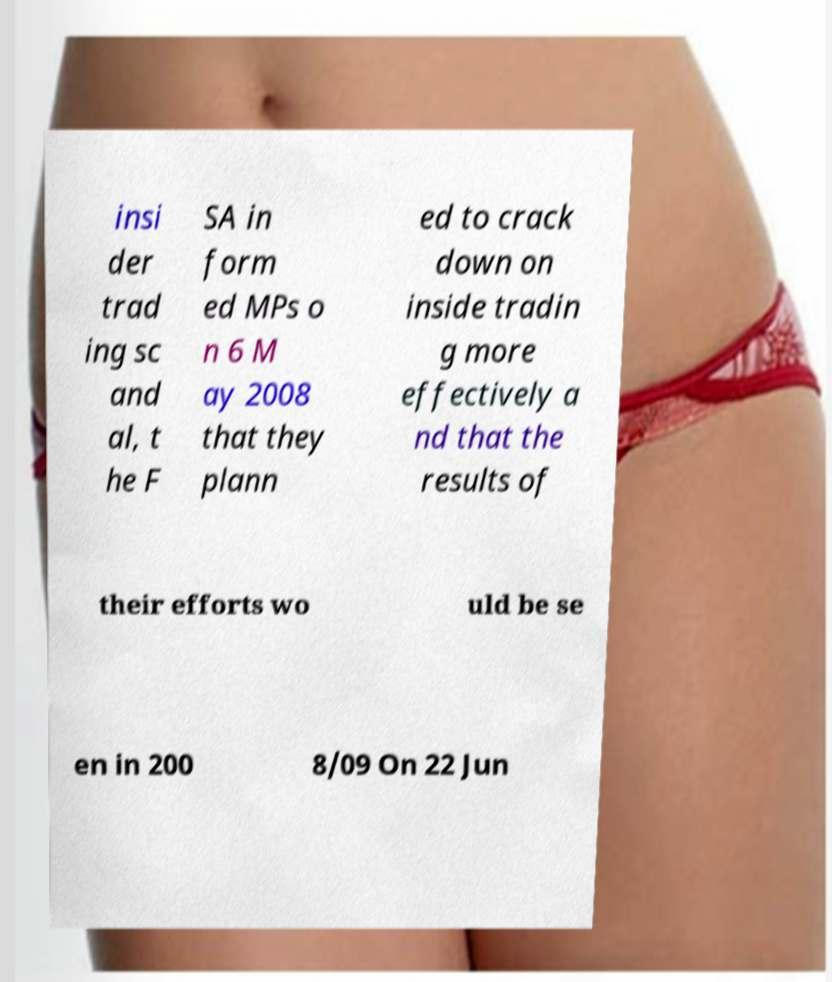For documentation purposes, I need the text within this image transcribed. Could you provide that? insi der trad ing sc and al, t he F SA in form ed MPs o n 6 M ay 2008 that they plann ed to crack down on inside tradin g more effectively a nd that the results of their efforts wo uld be se en in 200 8/09 On 22 Jun 